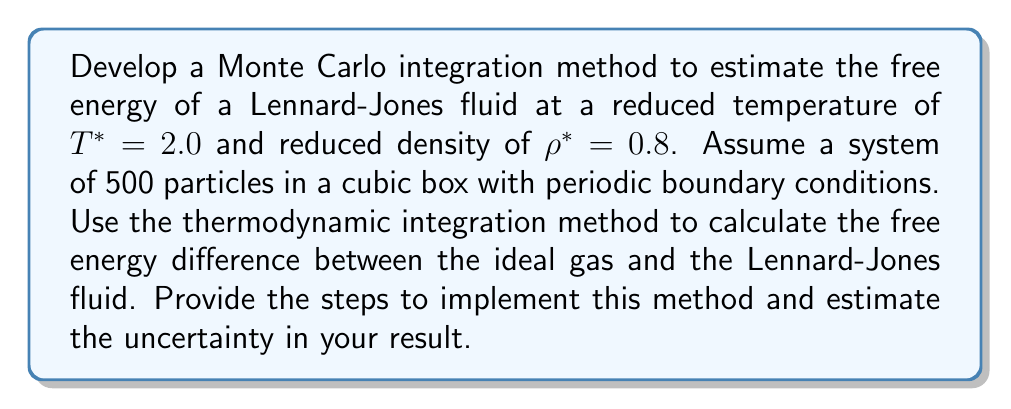Help me with this question. To estimate the free energy of a Lennard-Jones fluid using Monte Carlo integration and thermodynamic integration, follow these steps:

1. Set up the system:
   - Use reduced units: $T^* = 2.0$, $\rho^* = 0.8$, $N = 500$ particles
   - Calculate the box length: $L = (N/\rho^*)^{1/3}$

2. Define the Lennard-Jones potential:
   $$U_{LJ}(r) = 4\epsilon \left[ \left(\frac{\sigma}{r}\right)^{12} - \left(\frac{\sigma}{r}\right)^6 \right]$$
   where $\epsilon$ and $\sigma$ are the energy and length scales, respectively.

3. Implement thermodynamic integration:
   - Define a coupling parameter $\lambda \in [0,1]$ to interpolate between the ideal gas ($\lambda = 0$) and the Lennard-Jones fluid ($\lambda = 1$):
     $$U(\lambda) = \lambda U_{LJ}$$
   - The free energy difference is given by:
     $$\Delta F = F_{LJ} - F_{ideal} = \int_0^1 \left\langle \frac{\partial U(\lambda)}{\partial \lambda} \right\rangle_\lambda d\lambda$$

4. Set up the Monte Carlo simulation:
   - Initialize particle positions randomly in the box
   - Implement periodic boundary conditions
   - Use the Metropolis algorithm for particle moves

5. Perform Monte Carlo integration:
   - Choose a set of $\lambda$ values (e.g., $\lambda_i = 0, 0.1, 0.2, ..., 1.0$)
   - For each $\lambda_i$:
     a. Equilibrate the system
     b. Calculate $\left\langle \frac{\partial U(\lambda)}{\partial \lambda} \right\rangle_\lambda = \left\langle U_{LJ} \right\rangle_\lambda$ using MC sampling
     c. Estimate the uncertainty in $\left\langle U_{LJ} \right\rangle_\lambda$ using block averaging or bootstrap methods

6. Integrate the results:
   - Use numerical integration (e.g., trapezoidal rule) to compute $\Delta F$:
     $$\Delta F \approx \sum_{i=1}^{n-1} \frac{1}{2}(\lambda_{i+1} - \lambda_i) \left[ \left\langle U_{LJ} \right\rangle_{\lambda_{i+1}} + \left\langle U_{LJ} \right\rangle_{\lambda_i} \right]$$

7. Calculate the total free energy:
   - Compute the ideal gas free energy analytically:
     $$F_{ideal} = Nk_BT \left[ \ln(\rho\Lambda^3) - 1 \right]$$
     where $\Lambda$ is the thermal de Broglie wavelength
   - Calculate the Lennard-Jones fluid free energy:
     $$F_{LJ} = F_{ideal} + \Delta F$$

8. Estimate the uncertainty:
   - Propagate the uncertainties from the MC integration through the numerical integration
   - Report the final free energy with its uncertainty
Answer: $F_{LJ} = F_{ideal} + \int_0^1 \left\langle U_{LJ} \right\rangle_\lambda d\lambda$ 